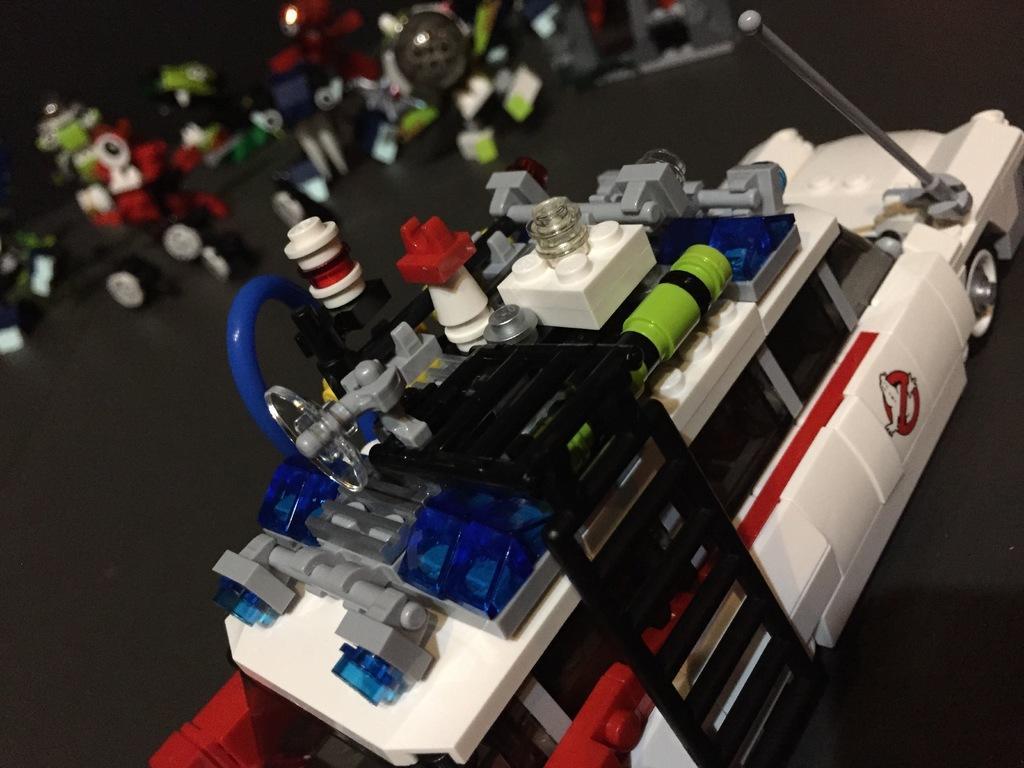In one or two sentences, can you explain what this image depicts? In the foreground of the picture there is a toy car it is white in color. In the background there are many toys. The table is grey in color. 